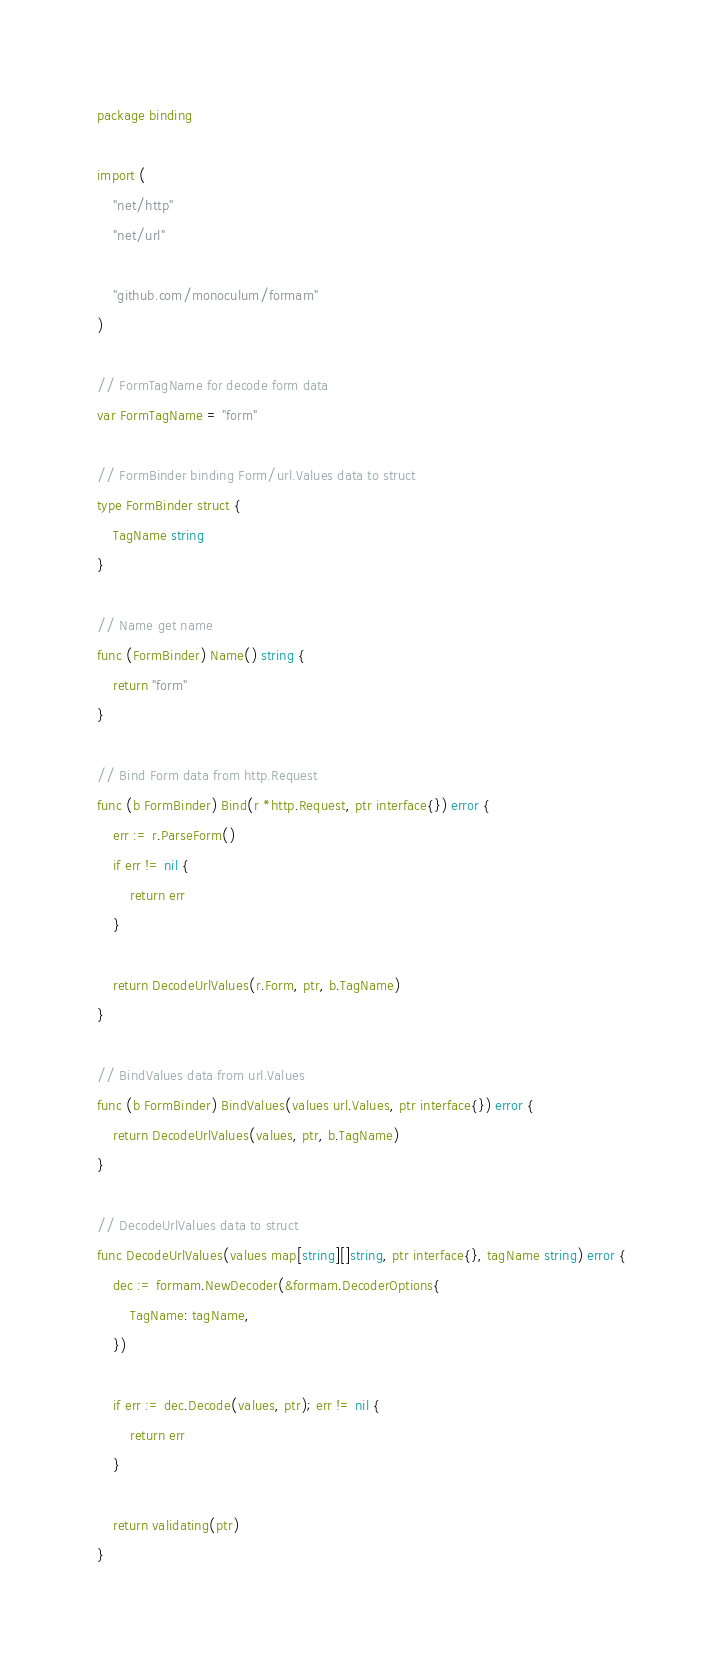<code> <loc_0><loc_0><loc_500><loc_500><_Go_>package binding

import (
	"net/http"
	"net/url"

	"github.com/monoculum/formam"
)

// FormTagName for decode form data
var FormTagName = "form"

// FormBinder binding Form/url.Values data to struct
type FormBinder struct {
	TagName string
}

// Name get name
func (FormBinder) Name() string {
	return "form"
}

// Bind Form data from http.Request
func (b FormBinder) Bind(r *http.Request, ptr interface{}) error {
	err := r.ParseForm()
	if err != nil {
		return err
	}

	return DecodeUrlValues(r.Form, ptr, b.TagName)
}

// BindValues data from url.Values
func (b FormBinder) BindValues(values url.Values, ptr interface{}) error {
	return DecodeUrlValues(values, ptr, b.TagName)
}

// DecodeUrlValues data to struct
func DecodeUrlValues(values map[string][]string, ptr interface{}, tagName string) error {
	dec := formam.NewDecoder(&formam.DecoderOptions{
		TagName: tagName,
	})

	if err := dec.Decode(values, ptr); err != nil {
		return err
	}

	return validating(ptr)
}
</code> 